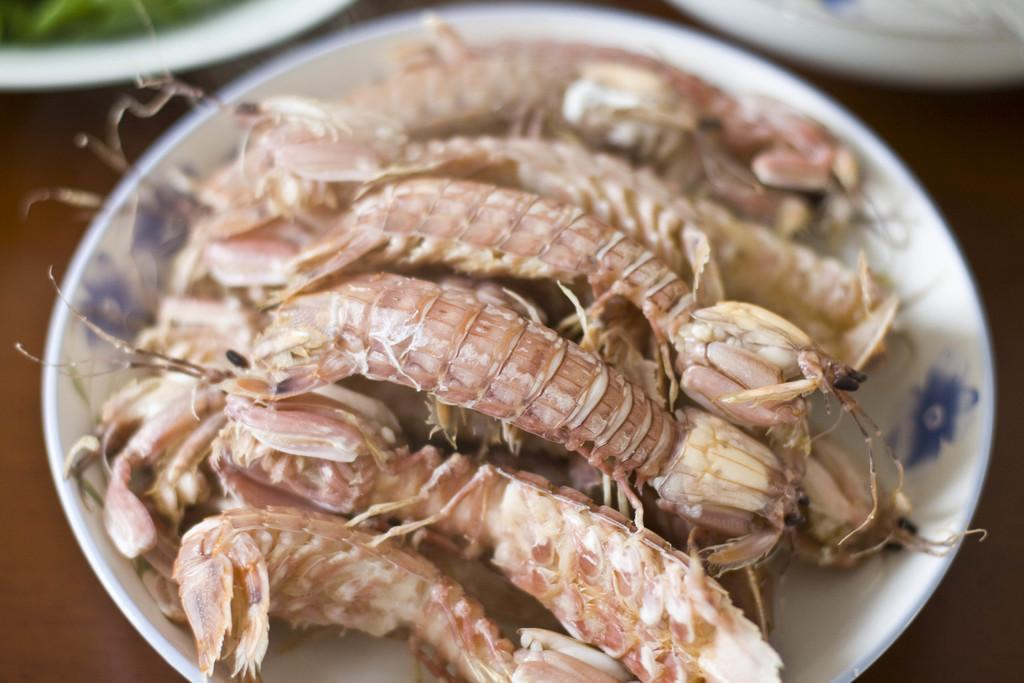What is on the plate that is visible in the image? There is food on a plate in the image. Where is the plate located in the image? The plate is in the center of the image. How many mice are crawling on the food in the image? There are no mice present in the image; it only shows a plate with food in the center. 